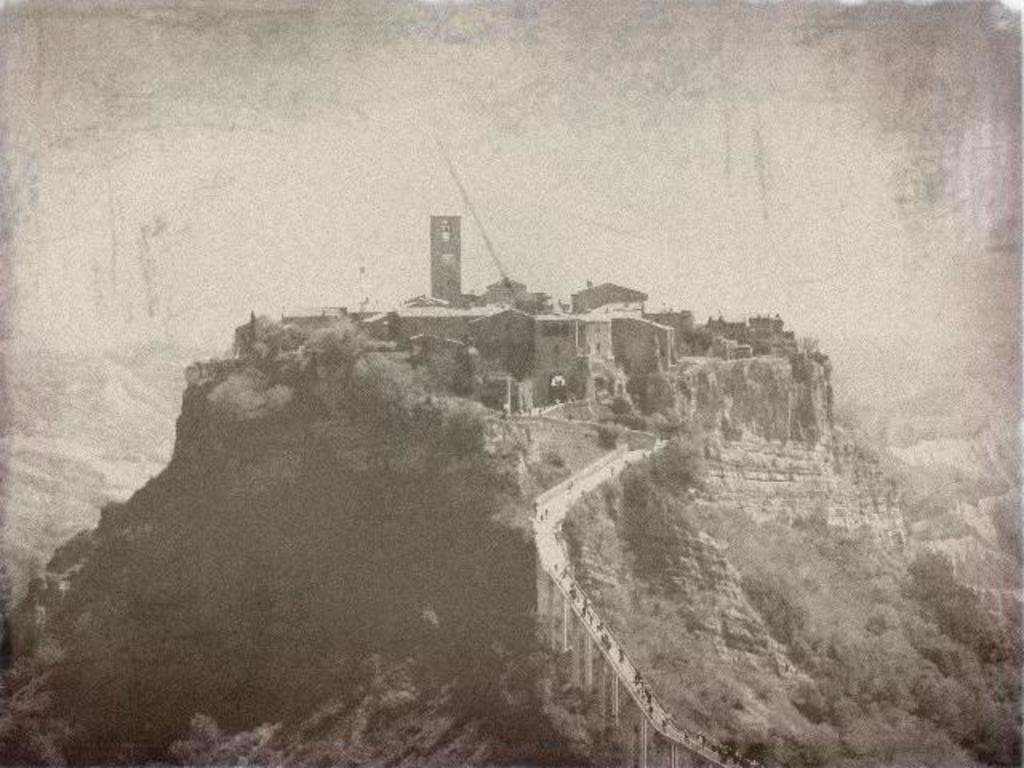Could you give a brief overview of what you see in this image? In this image I can see many trees, mountains and I can see few people on the bridge. In the background I can see many buildings and the sky. 